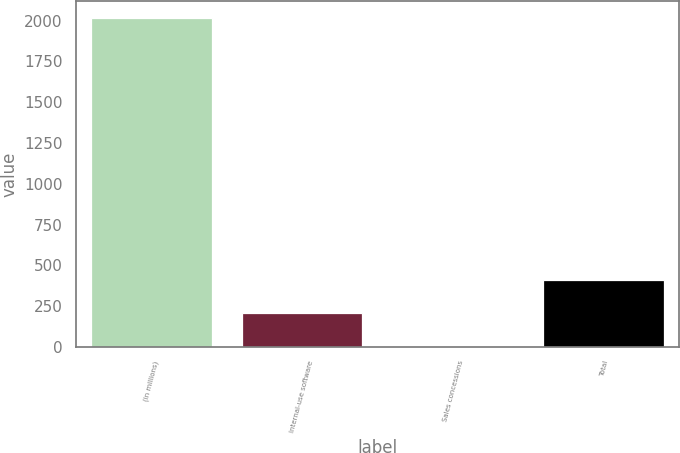Convert chart. <chart><loc_0><loc_0><loc_500><loc_500><bar_chart><fcel>(in millions)<fcel>Internal-use software<fcel>Sales concessions<fcel>Total<nl><fcel>2017<fcel>207.1<fcel>6<fcel>408.2<nl></chart> 